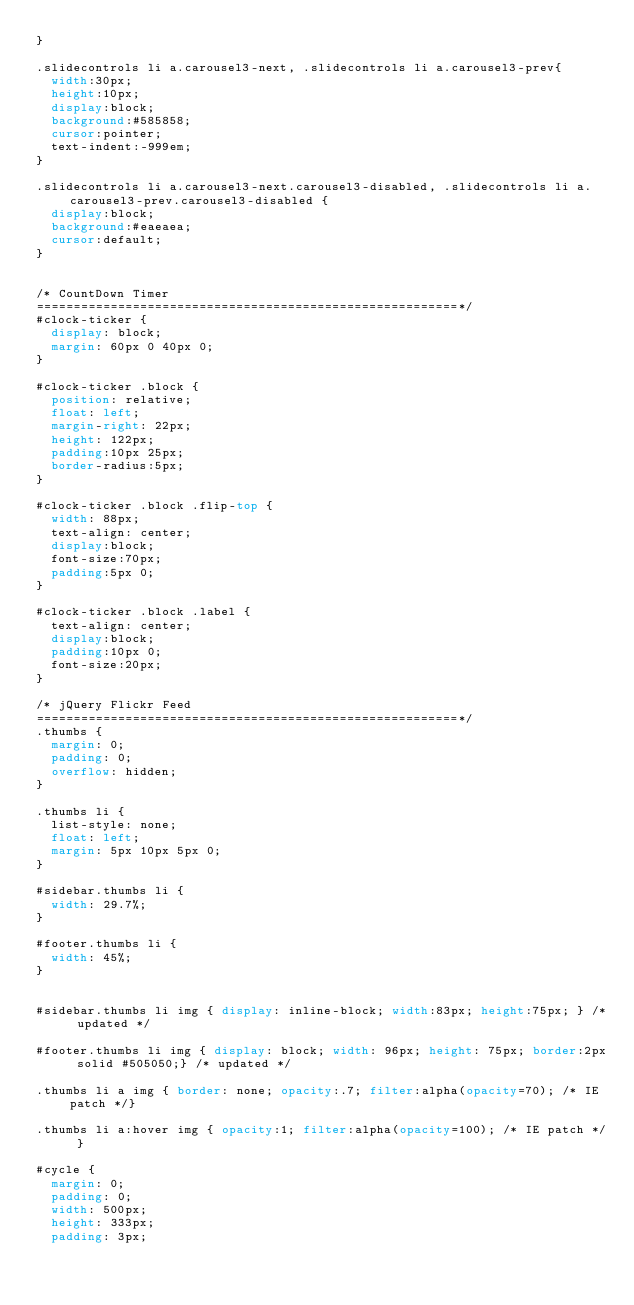<code> <loc_0><loc_0><loc_500><loc_500><_CSS_>}

.slidecontrols li a.carousel3-next, .slidecontrols li a.carousel3-prev{
	width:30px;
	height:10px;
	display:block;
	background:#585858;
	cursor:pointer;
	text-indent:-999em;
}

.slidecontrols li a.carousel3-next.carousel3-disabled, .slidecontrols li a.carousel3-prev.carousel3-disabled {
	display:block;
	background:#eaeaea;
	cursor:default;
}

 
/* CountDown Timer
=========================================================*/
#clock-ticker {
	display: block; 
	margin: 60px 0 40px 0;
}

#clock-ticker .block {
	position: relative;
	float: left; 
	margin-right: 22px; 
	height: 122px;
	padding:10px 25px;
	border-radius:5px;
}

#clock-ticker .block .flip-top {
	width: 88px; 
	text-align: center;
	display:block;
	font-size:70px;
	padding:5px 0;
}

#clock-ticker .block .label {
	text-align: center;
	display:block;
	padding:10px 0;
	font-size:20px;
}

/* jQuery Flickr Feed
=========================================================*/
.thumbs {
	margin: 0;
	padding: 0;
	overflow: hidden;
}

.thumbs li {
	list-style: none;
	float: left;
	margin: 5px 10px 5px 0;
}

#sidebar.thumbs li {
	width: 29.7%;
}

#footer.thumbs li {
	width: 45%;
}
	

#sidebar.thumbs li img { display: inline-block; width:83px; height:75px; } /* updated */

#footer.thumbs li img { display: block; width: 96px; height: 75px; border:2px solid #505050;} /* updated */

.thumbs li a img { border: none; opacity:.7; filter:alpha(opacity=70); /* IE patch */}

.thumbs li a:hover img { opacity:1; filter:alpha(opacity=100); /* IE patch */ }

#cycle {
	margin: 0;
	padding: 0;
	width: 500px;
	height: 333px;
	padding: 3px;</code> 